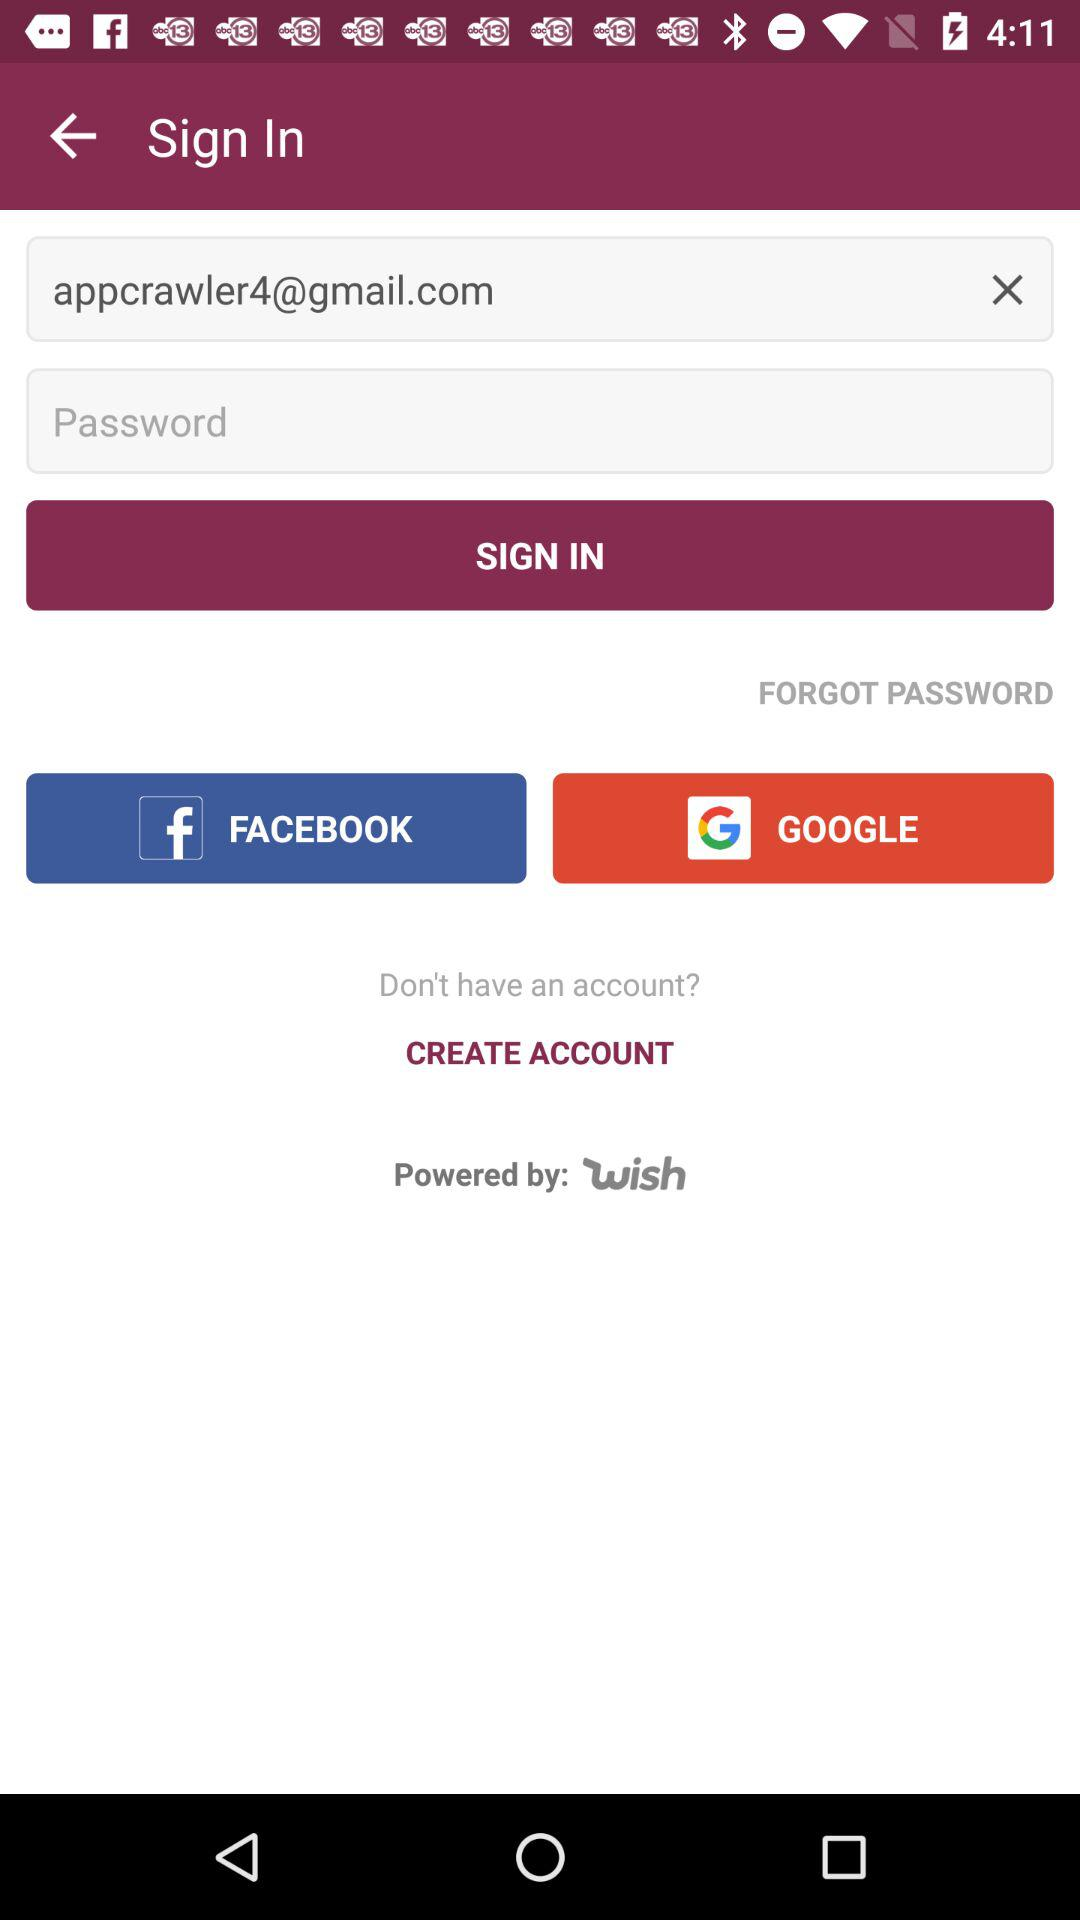Which other options are given for the sign-in? The other options that are given for the sign-in are "FACEBOOK" and "GOOGLE". 